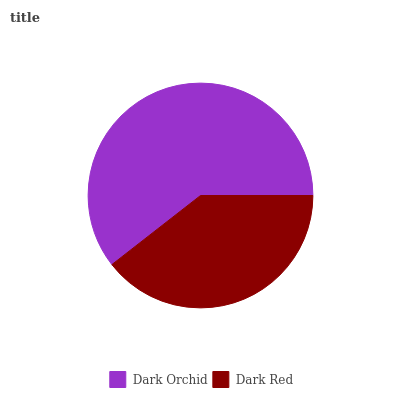Is Dark Red the minimum?
Answer yes or no. Yes. Is Dark Orchid the maximum?
Answer yes or no. Yes. Is Dark Red the maximum?
Answer yes or no. No. Is Dark Orchid greater than Dark Red?
Answer yes or no. Yes. Is Dark Red less than Dark Orchid?
Answer yes or no. Yes. Is Dark Red greater than Dark Orchid?
Answer yes or no. No. Is Dark Orchid less than Dark Red?
Answer yes or no. No. Is Dark Orchid the high median?
Answer yes or no. Yes. Is Dark Red the low median?
Answer yes or no. Yes. Is Dark Red the high median?
Answer yes or no. No. Is Dark Orchid the low median?
Answer yes or no. No. 